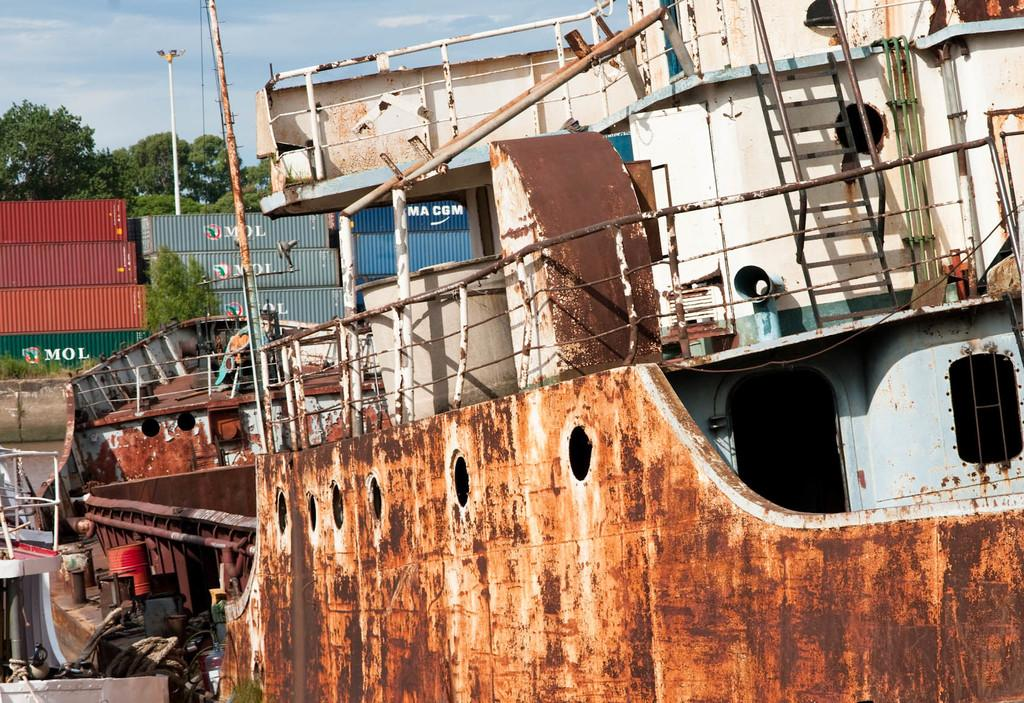Provide a one-sentence caption for the provided image. A rusty boat sits in front of MOL containers. 